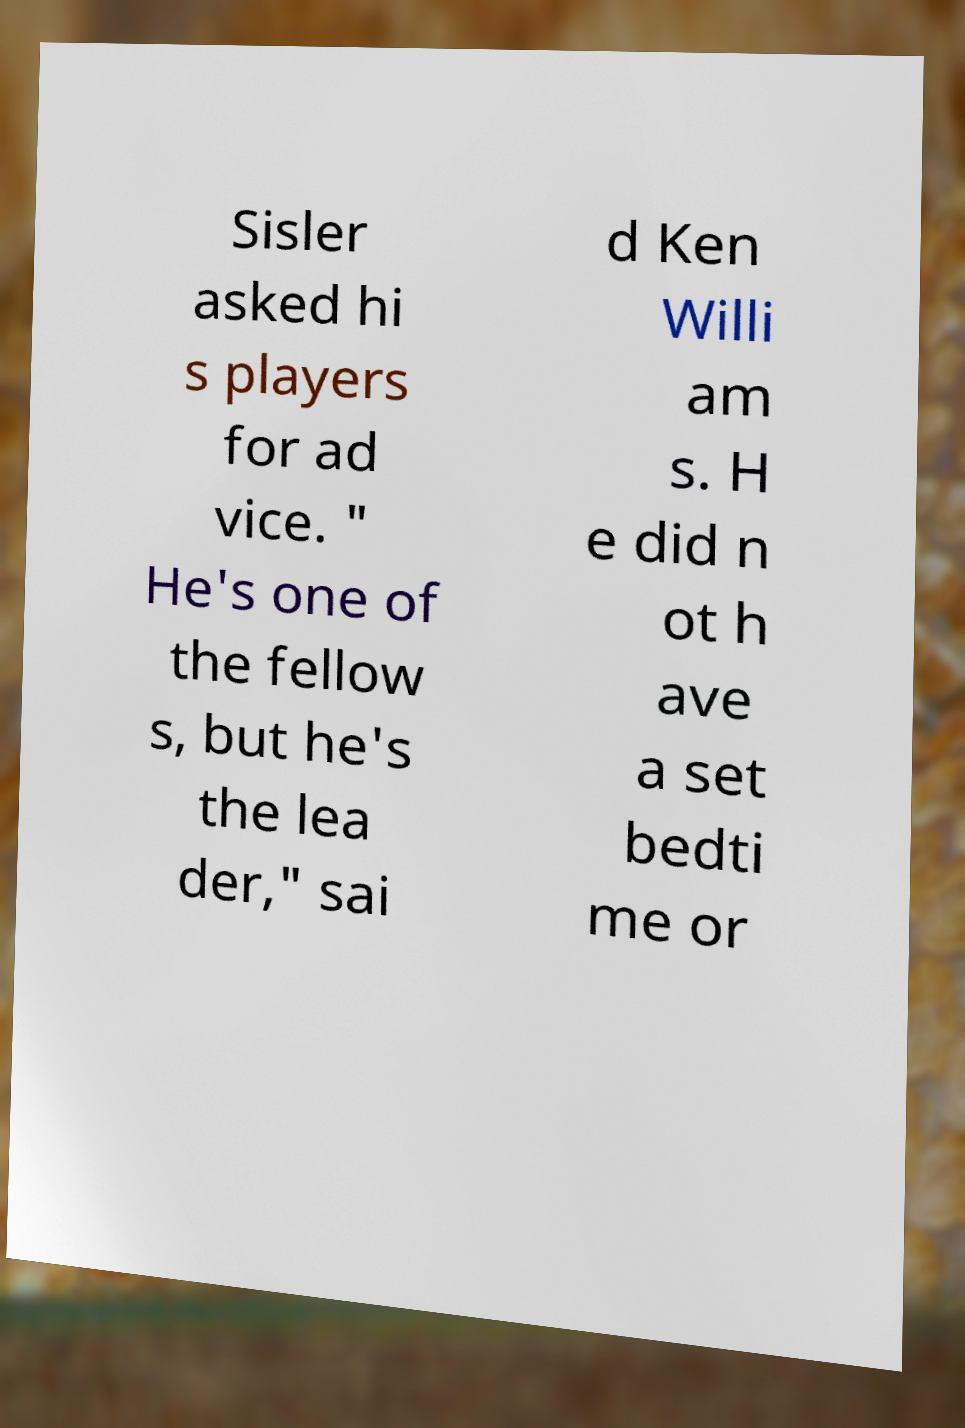Please read and relay the text visible in this image. What does it say? Sisler asked hi s players for ad vice. " He's one of the fellow s, but he's the lea der," sai d Ken Willi am s. H e did n ot h ave a set bedti me or 